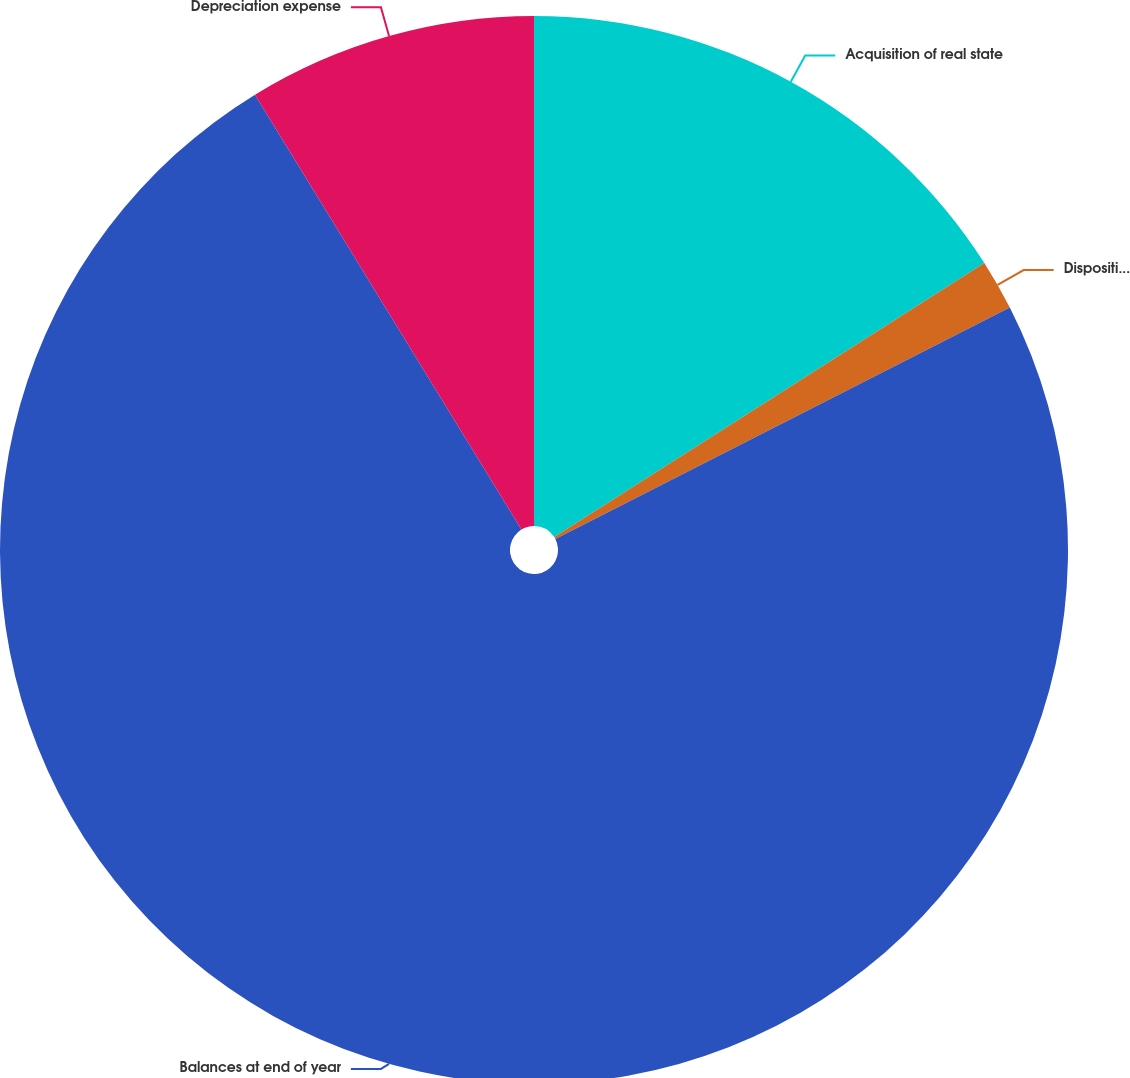Convert chart to OTSL. <chart><loc_0><loc_0><loc_500><loc_500><pie_chart><fcel>Acquisition of real state<fcel>Disposition of real estate<fcel>Balances at end of year<fcel>Depreciation expense<nl><fcel>15.97%<fcel>1.53%<fcel>73.75%<fcel>8.75%<nl></chart> 